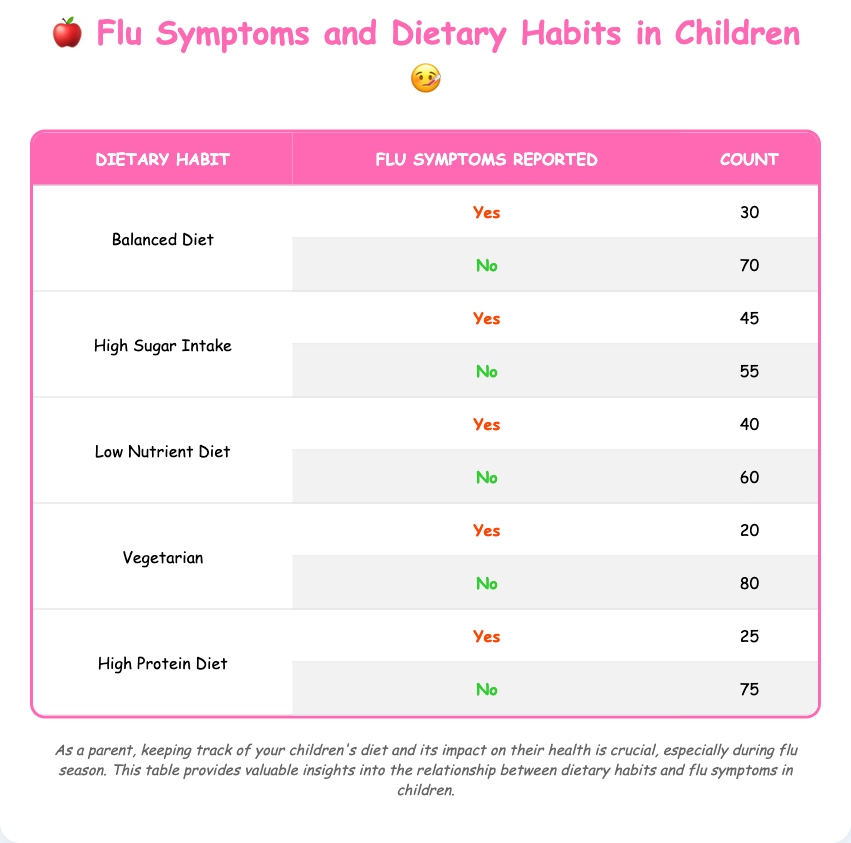What is the count of children on a balanced diet who reported flu symptoms? From the table, under the "Balanced Diet" category, the "Yes" for flu symptoms shows a count of 30.
Answer: 30 How many children with a high sugar intake reported not having flu symptoms? In the "High Sugar Intake" category, the "No" for flu symptoms shows a count of 55.
Answer: 55 What percentage of children with a low nutrient diet experienced flu symptoms? The total for "Low Nutrient Diet" is 40 (Yes) + 60 (No) = 100. The percentage that reported flu symptoms is (40 / 100) * 100 = 40%.
Answer: 40% Which dietary habit had the highest count of flu symptoms reported? Looking at the "Yes" counts across all dietary habits: Balanced Diet (30), High Sugar Intake (45), Low Nutrient Diet (40), Vegetarian (20), and High Protein Diet (25). High Sugar Intake with 45 has the highest count of flu symptoms reported.
Answer: High Sugar Intake Is it true that more children with a vegetarian diet reported flu symptoms than those on a high protein diet? For vegetarian children, the "Yes" count is 20, whereas for high protein diet children, the count is 25. Since 20 is less than 25, the statement is false.
Answer: No What is the total number of children who reported flu symptoms across all dietary habits? Adding the "Yes" counts: 30 (Balanced Diet) + 45 (High Sugar Intake) + 40 (Low Nutrient Diet) + 20 (Vegetarian) + 25 (High Protein Diet) gives a total of 30 + 45 + 40 + 20 + 25 = 160 children reported flu symptoms.
Answer: 160 Which dietary habit reported the least children with flu symptoms? The "Yes" counts for each dietary habit are: Balanced Diet (30), High Sugar Intake (45), Low Nutrient Diet (40), Vegetarian (20), and High Protein Diet (25). Vegetarian with 20 reported the least symptoms.
Answer: Vegetarian If a child is on a high sugar intake, what are the chances they experience flu symptoms? For high sugar intake, 45 out of 100 total children reported flu symptoms. The probability is calculated as (45 / 100) * 100 = 45%.
Answer: 45% What is the difference in flu symptom reports between children on a low nutrient diet and those on a balanced diet? "Low Nutrient Diet" has 40 (Yes) and "Balanced Diet" has 30 (Yes). The difference is 40 - 30 = 10 more flu symptoms in the low nutrient diet group.
Answer: 10 